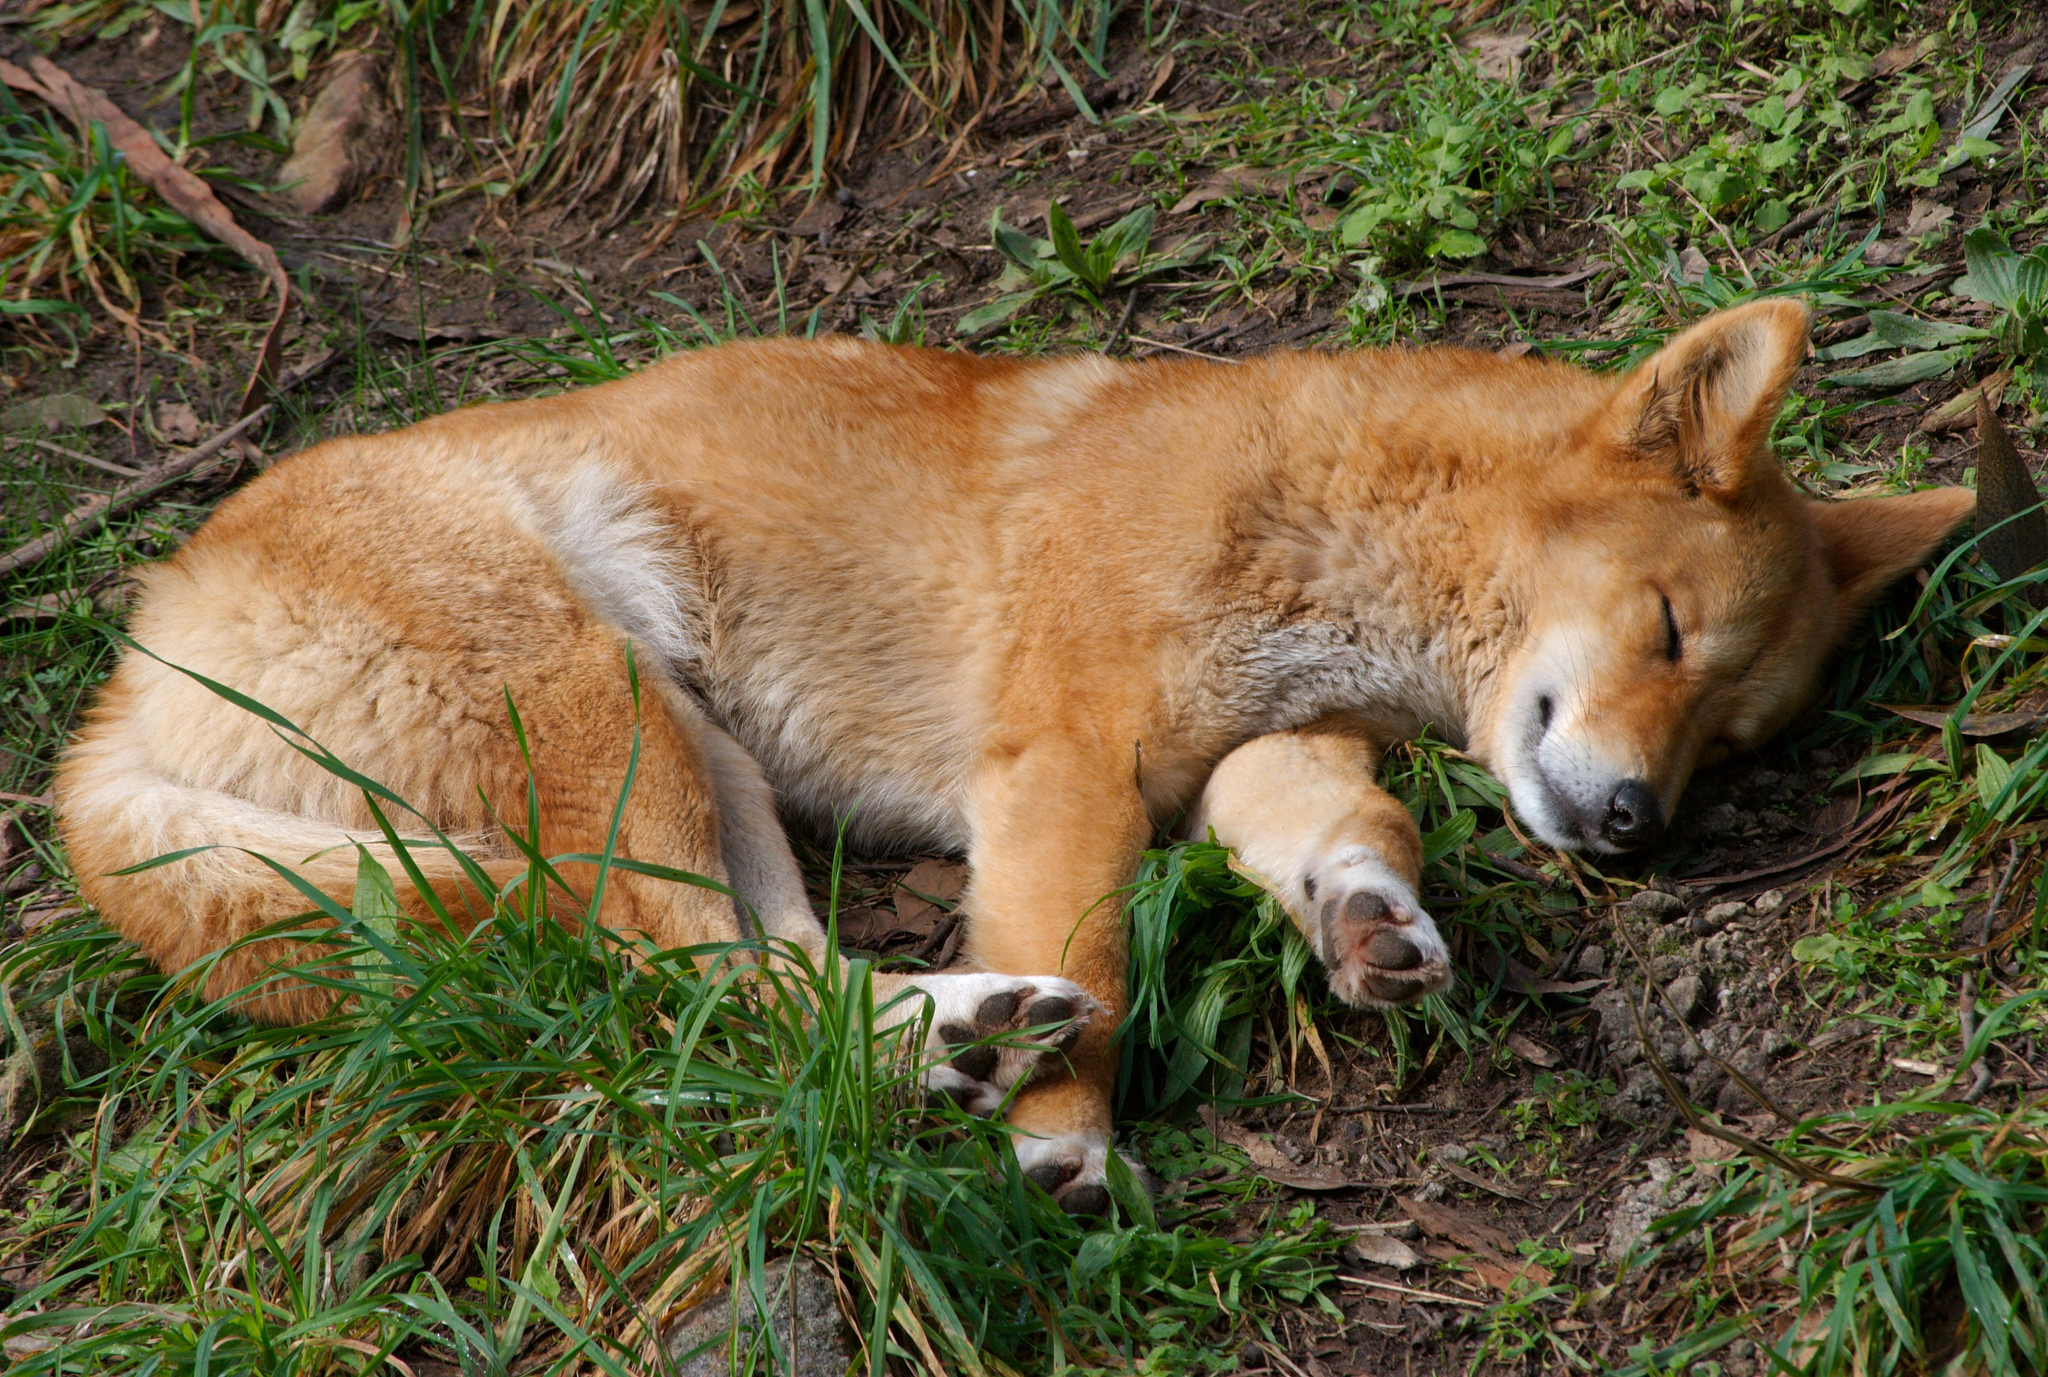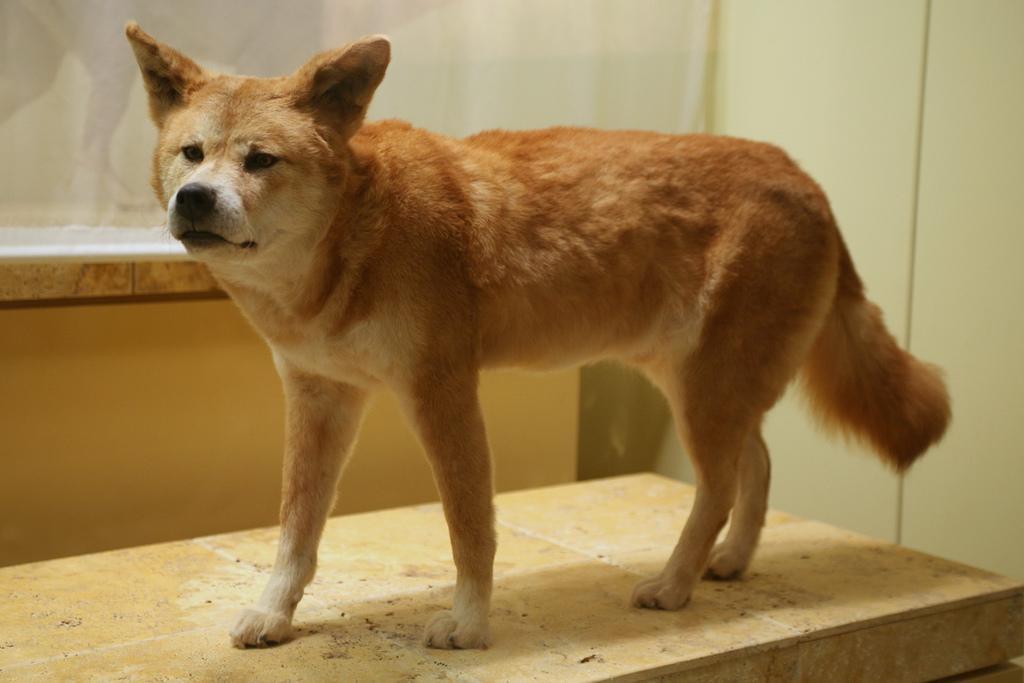The first image is the image on the left, the second image is the image on the right. For the images shown, is this caption "In the left image, a dog's eyes are narrowed because it looks sleepy." true? Answer yes or no. Yes. The first image is the image on the left, the second image is the image on the right. Given the left and right images, does the statement "The animal in the image on the right is standing on all fours." hold true? Answer yes or no. Yes. 